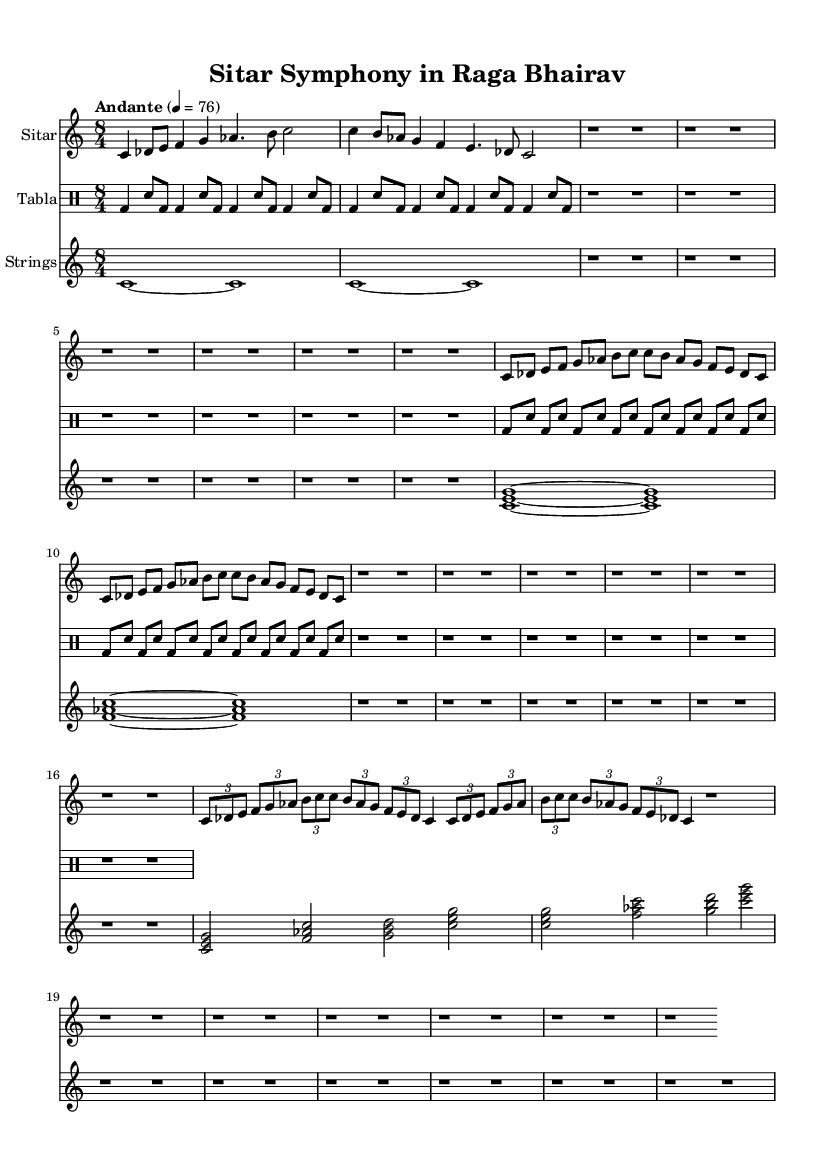What is the key signature of this music? The key signature is C major, which has no sharps or flats indicated on the staff. This is relevant for the tonal center around which the piece is composed.
Answer: C major What is the time signature of this music? The time signature is noted as 8/4, showing that there are eight beats in each measure, which gives a broader sense of rhythm typical of Hindustani classical music.
Answer: 8/4 What is the tempo marking for this piece? The tempo marking indicates "Andante," suggesting a moderately slow pace, which helps establish the mood of the composition and is specified as 4 = 76.
Answer: Andante How many measures are in the Alap section? The Alap section is composed of eight measures, as shown in the notation before moving into the Jor section.
Answer: 8 What instruments are included in this orchestration? The orchestration includes a Sitar, Tabla, and Strings, each represented in separate staves within the score, showing a fusion of traditional and orchestral sounds.
Answer: Sitar, Tabla, Strings Which section features faster rhythms and complex patterns? The Jhala section is characterized by faster rhythms and more intricate patterns, containing rapid elements compared to the earlier sections like Alap and Jor. This is indicated by the quick note groupings and dynamics.
Answer: Jhala How does the structure of this piece reflect typical characteristics of Hindustani classical music? The piece's structure includes the Alap, Jor, and Jhala sections, typical in Hindustani classical forms, allowing for a gradual development of themes and improvisation, showcasing the raga's expressiveness.
Answer: Alap, Jor, Jhala 